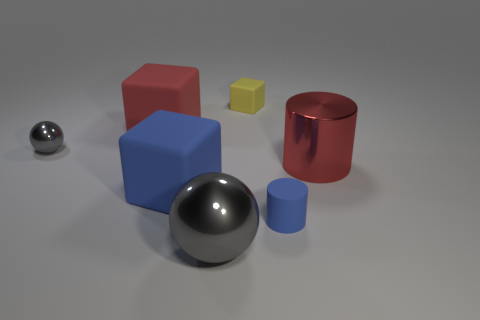Subtract 1 cubes. How many cubes are left? 2 Add 1 small gray things. How many objects exist? 8 Subtract all blocks. How many objects are left? 4 Subtract 0 green spheres. How many objects are left? 7 Subtract all big red matte cubes. Subtract all big red metallic objects. How many objects are left? 5 Add 5 small gray objects. How many small gray objects are left? 6 Add 2 small brown rubber cubes. How many small brown rubber cubes exist? 2 